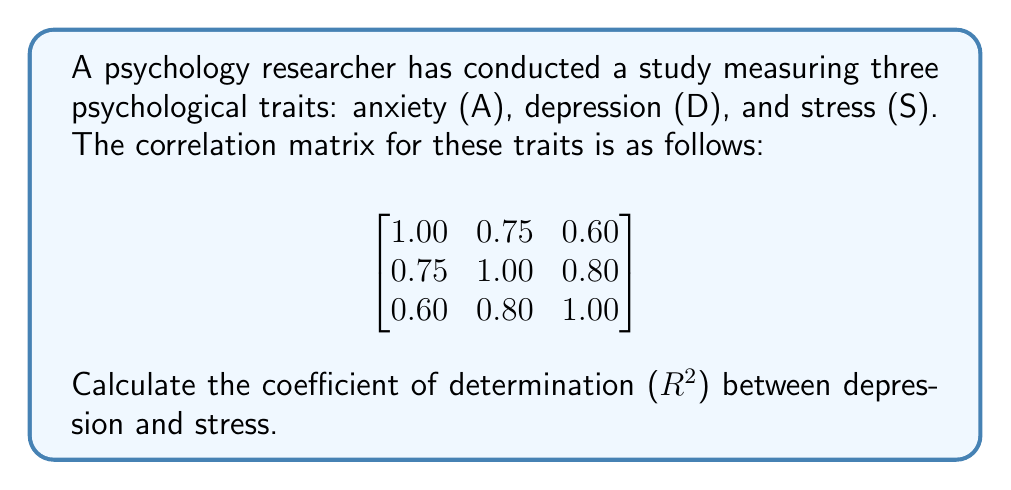Can you solve this math problem? To solve this problem, we'll follow these steps:

1. Identify the correlation coefficient:
   The correlation coefficient between depression (D) and stress (S) is given in the matrix at position (2,3) or (3,2), which is 0.80.

2. Calculate the coefficient of determination (R²):
   The coefficient of determination is the square of the correlation coefficient.

   $R^2 = r^2$
   
   Where $r$ is the correlation coefficient.

3. Plug in the values:
   $R^2 = (0.80)^2$

4. Compute the result:
   $R^2 = 0.64$

5. Interpret the result:
   This means that 64% of the variance in depression scores can be explained by the variance in stress scores, or vice versa.
Answer: 0.64 